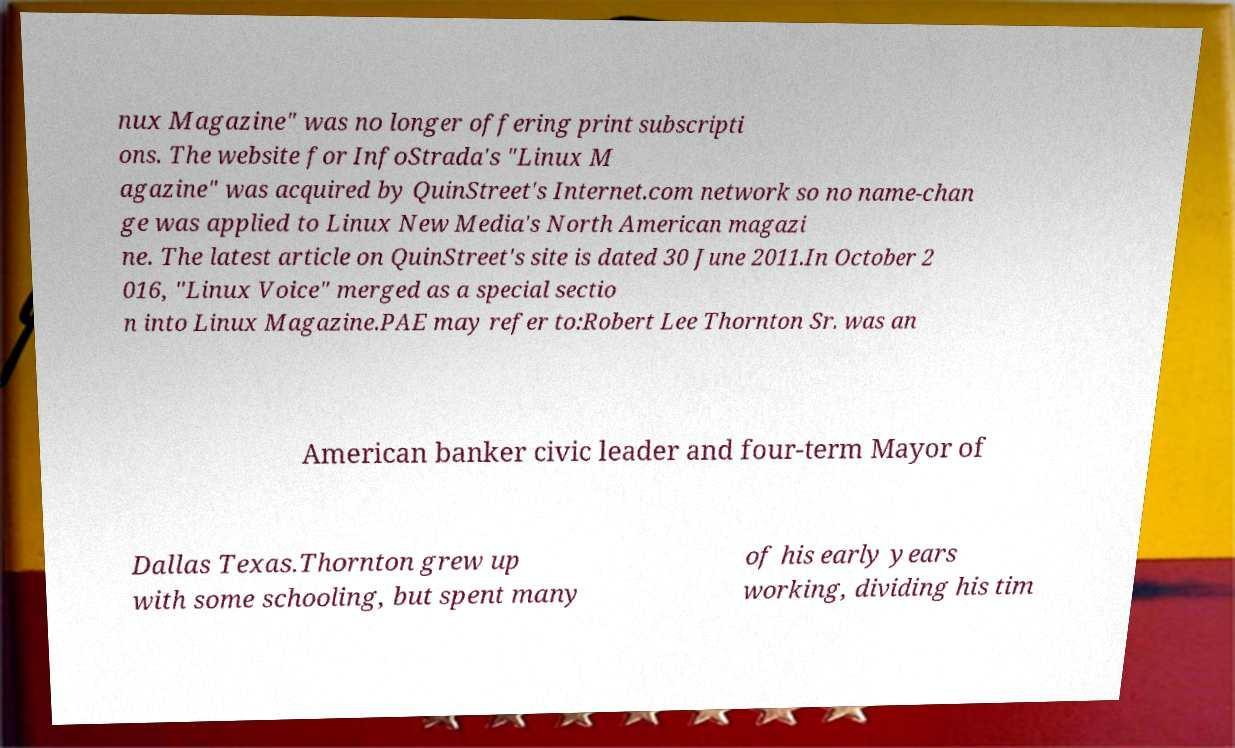I need the written content from this picture converted into text. Can you do that? nux Magazine" was no longer offering print subscripti ons. The website for InfoStrada's "Linux M agazine" was acquired by QuinStreet's Internet.com network so no name-chan ge was applied to Linux New Media's North American magazi ne. The latest article on QuinStreet's site is dated 30 June 2011.In October 2 016, "Linux Voice" merged as a special sectio n into Linux Magazine.PAE may refer to:Robert Lee Thornton Sr. was an American banker civic leader and four-term Mayor of Dallas Texas.Thornton grew up with some schooling, but spent many of his early years working, dividing his tim 